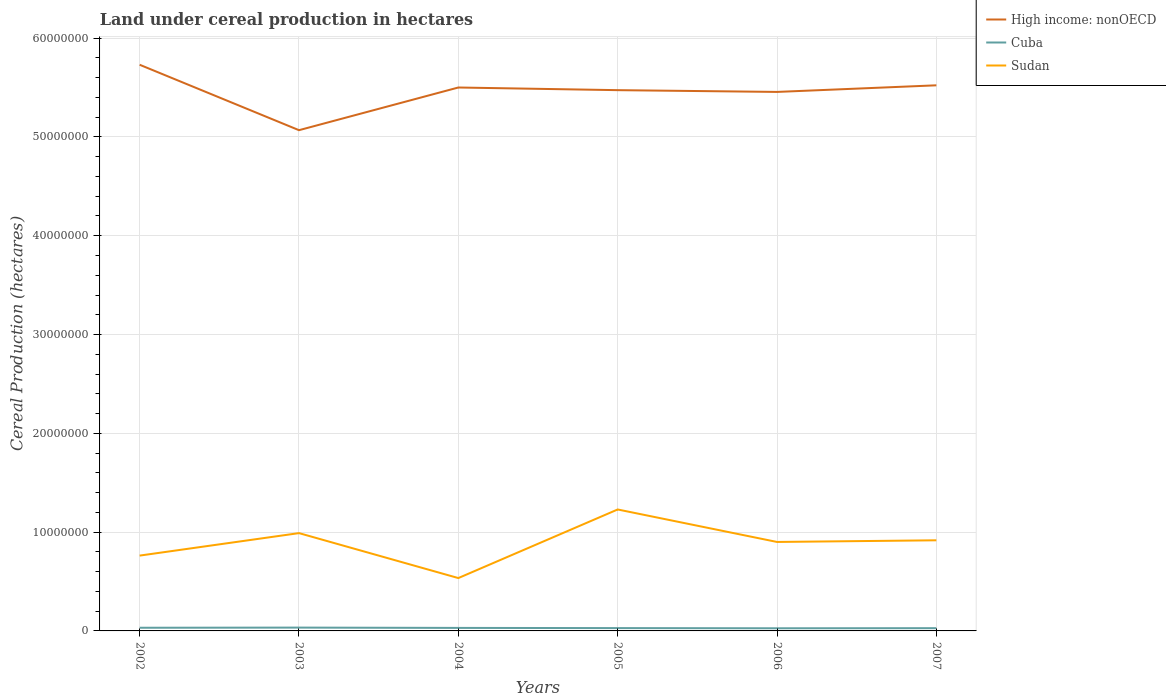Is the number of lines equal to the number of legend labels?
Make the answer very short. Yes. Across all years, what is the maximum land under cereal production in Cuba?
Ensure brevity in your answer.  2.67e+05. What is the total land under cereal production in Sudan in the graph?
Give a very brief answer. -1.38e+06. What is the difference between the highest and the second highest land under cereal production in High income: nonOECD?
Provide a short and direct response. 6.62e+06. What is the difference between the highest and the lowest land under cereal production in Cuba?
Offer a terse response. 3. Is the land under cereal production in High income: nonOECD strictly greater than the land under cereal production in Cuba over the years?
Give a very brief answer. No. How many lines are there?
Offer a very short reply. 3. What is the difference between two consecutive major ticks on the Y-axis?
Offer a terse response. 1.00e+07. What is the title of the graph?
Make the answer very short. Land under cereal production in hectares. Does "Germany" appear as one of the legend labels in the graph?
Your answer should be very brief. No. What is the label or title of the X-axis?
Offer a very short reply. Years. What is the label or title of the Y-axis?
Offer a very short reply. Cereal Production (hectares). What is the Cereal Production (hectares) of High income: nonOECD in 2002?
Your response must be concise. 5.73e+07. What is the Cereal Production (hectares) of Cuba in 2002?
Your answer should be compact. 3.21e+05. What is the Cereal Production (hectares) of Sudan in 2002?
Give a very brief answer. 7.62e+06. What is the Cereal Production (hectares) in High income: nonOECD in 2003?
Your answer should be compact. 5.07e+07. What is the Cereal Production (hectares) of Cuba in 2003?
Provide a short and direct response. 3.37e+05. What is the Cereal Production (hectares) in Sudan in 2003?
Your response must be concise. 9.90e+06. What is the Cereal Production (hectares) of High income: nonOECD in 2004?
Provide a short and direct response. 5.50e+07. What is the Cereal Production (hectares) of Cuba in 2004?
Offer a very short reply. 3.04e+05. What is the Cereal Production (hectares) in Sudan in 2004?
Give a very brief answer. 5.35e+06. What is the Cereal Production (hectares) in High income: nonOECD in 2005?
Provide a short and direct response. 5.47e+07. What is the Cereal Production (hectares) in Cuba in 2005?
Keep it short and to the point. 2.86e+05. What is the Cereal Production (hectares) in Sudan in 2005?
Provide a succinct answer. 1.23e+07. What is the Cereal Production (hectares) of High income: nonOECD in 2006?
Your response must be concise. 5.46e+07. What is the Cereal Production (hectares) of Cuba in 2006?
Provide a short and direct response. 2.67e+05. What is the Cereal Production (hectares) in Sudan in 2006?
Your response must be concise. 9.00e+06. What is the Cereal Production (hectares) of High income: nonOECD in 2007?
Offer a terse response. 5.52e+07. What is the Cereal Production (hectares) of Cuba in 2007?
Your answer should be compact. 2.78e+05. What is the Cereal Production (hectares) of Sudan in 2007?
Keep it short and to the point. 9.17e+06. Across all years, what is the maximum Cereal Production (hectares) of High income: nonOECD?
Keep it short and to the point. 5.73e+07. Across all years, what is the maximum Cereal Production (hectares) in Cuba?
Ensure brevity in your answer.  3.37e+05. Across all years, what is the maximum Cereal Production (hectares) of Sudan?
Your answer should be compact. 1.23e+07. Across all years, what is the minimum Cereal Production (hectares) of High income: nonOECD?
Provide a succinct answer. 5.07e+07. Across all years, what is the minimum Cereal Production (hectares) in Cuba?
Offer a very short reply. 2.67e+05. Across all years, what is the minimum Cereal Production (hectares) in Sudan?
Give a very brief answer. 5.35e+06. What is the total Cereal Production (hectares) of High income: nonOECD in the graph?
Make the answer very short. 3.28e+08. What is the total Cereal Production (hectares) of Cuba in the graph?
Ensure brevity in your answer.  1.79e+06. What is the total Cereal Production (hectares) of Sudan in the graph?
Provide a short and direct response. 5.33e+07. What is the difference between the Cereal Production (hectares) in High income: nonOECD in 2002 and that in 2003?
Give a very brief answer. 6.62e+06. What is the difference between the Cereal Production (hectares) of Cuba in 2002 and that in 2003?
Ensure brevity in your answer.  -1.69e+04. What is the difference between the Cereal Production (hectares) in Sudan in 2002 and that in 2003?
Ensure brevity in your answer.  -2.28e+06. What is the difference between the Cereal Production (hectares) of High income: nonOECD in 2002 and that in 2004?
Ensure brevity in your answer.  2.30e+06. What is the difference between the Cereal Production (hectares) of Cuba in 2002 and that in 2004?
Keep it short and to the point. 1.61e+04. What is the difference between the Cereal Production (hectares) in Sudan in 2002 and that in 2004?
Give a very brief answer. 2.27e+06. What is the difference between the Cereal Production (hectares) in High income: nonOECD in 2002 and that in 2005?
Make the answer very short. 2.57e+06. What is the difference between the Cereal Production (hectares) of Cuba in 2002 and that in 2005?
Offer a terse response. 3.47e+04. What is the difference between the Cereal Production (hectares) in Sudan in 2002 and that in 2005?
Offer a terse response. -4.67e+06. What is the difference between the Cereal Production (hectares) of High income: nonOECD in 2002 and that in 2006?
Make the answer very short. 2.75e+06. What is the difference between the Cereal Production (hectares) of Cuba in 2002 and that in 2006?
Your answer should be compact. 5.32e+04. What is the difference between the Cereal Production (hectares) of Sudan in 2002 and that in 2006?
Offer a very short reply. -1.38e+06. What is the difference between the Cereal Production (hectares) in High income: nonOECD in 2002 and that in 2007?
Your answer should be very brief. 2.08e+06. What is the difference between the Cereal Production (hectares) of Cuba in 2002 and that in 2007?
Make the answer very short. 4.27e+04. What is the difference between the Cereal Production (hectares) of Sudan in 2002 and that in 2007?
Give a very brief answer. -1.55e+06. What is the difference between the Cereal Production (hectares) of High income: nonOECD in 2003 and that in 2004?
Give a very brief answer. -4.32e+06. What is the difference between the Cereal Production (hectares) of Cuba in 2003 and that in 2004?
Your response must be concise. 3.30e+04. What is the difference between the Cereal Production (hectares) of Sudan in 2003 and that in 2004?
Provide a succinct answer. 4.55e+06. What is the difference between the Cereal Production (hectares) in High income: nonOECD in 2003 and that in 2005?
Provide a short and direct response. -4.05e+06. What is the difference between the Cereal Production (hectares) of Cuba in 2003 and that in 2005?
Offer a terse response. 5.16e+04. What is the difference between the Cereal Production (hectares) of Sudan in 2003 and that in 2005?
Ensure brevity in your answer.  -2.39e+06. What is the difference between the Cereal Production (hectares) in High income: nonOECD in 2003 and that in 2006?
Give a very brief answer. -3.87e+06. What is the difference between the Cereal Production (hectares) of Cuba in 2003 and that in 2006?
Provide a succinct answer. 7.00e+04. What is the difference between the Cereal Production (hectares) of Sudan in 2003 and that in 2006?
Your response must be concise. 8.95e+05. What is the difference between the Cereal Production (hectares) in High income: nonOECD in 2003 and that in 2007?
Your response must be concise. -4.54e+06. What is the difference between the Cereal Production (hectares) of Cuba in 2003 and that in 2007?
Give a very brief answer. 5.95e+04. What is the difference between the Cereal Production (hectares) of Sudan in 2003 and that in 2007?
Make the answer very short. 7.27e+05. What is the difference between the Cereal Production (hectares) of High income: nonOECD in 2004 and that in 2005?
Ensure brevity in your answer.  2.69e+05. What is the difference between the Cereal Production (hectares) in Cuba in 2004 and that in 2005?
Provide a succinct answer. 1.86e+04. What is the difference between the Cereal Production (hectares) in Sudan in 2004 and that in 2005?
Ensure brevity in your answer.  -6.94e+06. What is the difference between the Cereal Production (hectares) in High income: nonOECD in 2004 and that in 2006?
Your response must be concise. 4.48e+05. What is the difference between the Cereal Production (hectares) in Cuba in 2004 and that in 2006?
Give a very brief answer. 3.70e+04. What is the difference between the Cereal Production (hectares) of Sudan in 2004 and that in 2006?
Give a very brief answer. -3.65e+06. What is the difference between the Cereal Production (hectares) of High income: nonOECD in 2004 and that in 2007?
Your answer should be compact. -2.21e+05. What is the difference between the Cereal Production (hectares) of Cuba in 2004 and that in 2007?
Your response must be concise. 2.65e+04. What is the difference between the Cereal Production (hectares) of Sudan in 2004 and that in 2007?
Provide a short and direct response. -3.82e+06. What is the difference between the Cereal Production (hectares) in High income: nonOECD in 2005 and that in 2006?
Your answer should be compact. 1.79e+05. What is the difference between the Cereal Production (hectares) of Cuba in 2005 and that in 2006?
Provide a short and direct response. 1.84e+04. What is the difference between the Cereal Production (hectares) of Sudan in 2005 and that in 2006?
Your response must be concise. 3.29e+06. What is the difference between the Cereal Production (hectares) in High income: nonOECD in 2005 and that in 2007?
Keep it short and to the point. -4.91e+05. What is the difference between the Cereal Production (hectares) of Cuba in 2005 and that in 2007?
Your answer should be compact. 7947. What is the difference between the Cereal Production (hectares) of Sudan in 2005 and that in 2007?
Make the answer very short. 3.12e+06. What is the difference between the Cereal Production (hectares) in High income: nonOECD in 2006 and that in 2007?
Your answer should be compact. -6.69e+05. What is the difference between the Cereal Production (hectares) in Cuba in 2006 and that in 2007?
Your answer should be compact. -1.05e+04. What is the difference between the Cereal Production (hectares) in Sudan in 2006 and that in 2007?
Your response must be concise. -1.68e+05. What is the difference between the Cereal Production (hectares) of High income: nonOECD in 2002 and the Cereal Production (hectares) of Cuba in 2003?
Your answer should be compact. 5.70e+07. What is the difference between the Cereal Production (hectares) of High income: nonOECD in 2002 and the Cereal Production (hectares) of Sudan in 2003?
Your answer should be very brief. 4.74e+07. What is the difference between the Cereal Production (hectares) of Cuba in 2002 and the Cereal Production (hectares) of Sudan in 2003?
Make the answer very short. -9.58e+06. What is the difference between the Cereal Production (hectares) in High income: nonOECD in 2002 and the Cereal Production (hectares) in Cuba in 2004?
Your response must be concise. 5.70e+07. What is the difference between the Cereal Production (hectares) of High income: nonOECD in 2002 and the Cereal Production (hectares) of Sudan in 2004?
Offer a very short reply. 5.20e+07. What is the difference between the Cereal Production (hectares) of Cuba in 2002 and the Cereal Production (hectares) of Sudan in 2004?
Make the answer very short. -5.03e+06. What is the difference between the Cereal Production (hectares) in High income: nonOECD in 2002 and the Cereal Production (hectares) in Cuba in 2005?
Your answer should be compact. 5.70e+07. What is the difference between the Cereal Production (hectares) in High income: nonOECD in 2002 and the Cereal Production (hectares) in Sudan in 2005?
Offer a very short reply. 4.50e+07. What is the difference between the Cereal Production (hectares) in Cuba in 2002 and the Cereal Production (hectares) in Sudan in 2005?
Your answer should be compact. -1.20e+07. What is the difference between the Cereal Production (hectares) in High income: nonOECD in 2002 and the Cereal Production (hectares) in Cuba in 2006?
Offer a very short reply. 5.70e+07. What is the difference between the Cereal Production (hectares) in High income: nonOECD in 2002 and the Cereal Production (hectares) in Sudan in 2006?
Keep it short and to the point. 4.83e+07. What is the difference between the Cereal Production (hectares) in Cuba in 2002 and the Cereal Production (hectares) in Sudan in 2006?
Make the answer very short. -8.68e+06. What is the difference between the Cereal Production (hectares) in High income: nonOECD in 2002 and the Cereal Production (hectares) in Cuba in 2007?
Provide a short and direct response. 5.70e+07. What is the difference between the Cereal Production (hectares) in High income: nonOECD in 2002 and the Cereal Production (hectares) in Sudan in 2007?
Keep it short and to the point. 4.81e+07. What is the difference between the Cereal Production (hectares) in Cuba in 2002 and the Cereal Production (hectares) in Sudan in 2007?
Provide a succinct answer. -8.85e+06. What is the difference between the Cereal Production (hectares) of High income: nonOECD in 2003 and the Cereal Production (hectares) of Cuba in 2004?
Offer a terse response. 5.04e+07. What is the difference between the Cereal Production (hectares) in High income: nonOECD in 2003 and the Cereal Production (hectares) in Sudan in 2004?
Keep it short and to the point. 4.53e+07. What is the difference between the Cereal Production (hectares) in Cuba in 2003 and the Cereal Production (hectares) in Sudan in 2004?
Offer a terse response. -5.01e+06. What is the difference between the Cereal Production (hectares) in High income: nonOECD in 2003 and the Cereal Production (hectares) in Cuba in 2005?
Provide a succinct answer. 5.04e+07. What is the difference between the Cereal Production (hectares) in High income: nonOECD in 2003 and the Cereal Production (hectares) in Sudan in 2005?
Ensure brevity in your answer.  3.84e+07. What is the difference between the Cereal Production (hectares) of Cuba in 2003 and the Cereal Production (hectares) of Sudan in 2005?
Your response must be concise. -1.20e+07. What is the difference between the Cereal Production (hectares) of High income: nonOECD in 2003 and the Cereal Production (hectares) of Cuba in 2006?
Give a very brief answer. 5.04e+07. What is the difference between the Cereal Production (hectares) in High income: nonOECD in 2003 and the Cereal Production (hectares) in Sudan in 2006?
Provide a succinct answer. 4.17e+07. What is the difference between the Cereal Production (hectares) of Cuba in 2003 and the Cereal Production (hectares) of Sudan in 2006?
Your answer should be compact. -8.67e+06. What is the difference between the Cereal Production (hectares) in High income: nonOECD in 2003 and the Cereal Production (hectares) in Cuba in 2007?
Provide a succinct answer. 5.04e+07. What is the difference between the Cereal Production (hectares) in High income: nonOECD in 2003 and the Cereal Production (hectares) in Sudan in 2007?
Offer a very short reply. 4.15e+07. What is the difference between the Cereal Production (hectares) of Cuba in 2003 and the Cereal Production (hectares) of Sudan in 2007?
Your answer should be very brief. -8.84e+06. What is the difference between the Cereal Production (hectares) in High income: nonOECD in 2004 and the Cereal Production (hectares) in Cuba in 2005?
Make the answer very short. 5.47e+07. What is the difference between the Cereal Production (hectares) in High income: nonOECD in 2004 and the Cereal Production (hectares) in Sudan in 2005?
Keep it short and to the point. 4.27e+07. What is the difference between the Cereal Production (hectares) in Cuba in 2004 and the Cereal Production (hectares) in Sudan in 2005?
Offer a very short reply. -1.20e+07. What is the difference between the Cereal Production (hectares) in High income: nonOECD in 2004 and the Cereal Production (hectares) in Cuba in 2006?
Ensure brevity in your answer.  5.47e+07. What is the difference between the Cereal Production (hectares) in High income: nonOECD in 2004 and the Cereal Production (hectares) in Sudan in 2006?
Give a very brief answer. 4.60e+07. What is the difference between the Cereal Production (hectares) in Cuba in 2004 and the Cereal Production (hectares) in Sudan in 2006?
Give a very brief answer. -8.70e+06. What is the difference between the Cereal Production (hectares) of High income: nonOECD in 2004 and the Cereal Production (hectares) of Cuba in 2007?
Give a very brief answer. 5.47e+07. What is the difference between the Cereal Production (hectares) in High income: nonOECD in 2004 and the Cereal Production (hectares) in Sudan in 2007?
Ensure brevity in your answer.  4.58e+07. What is the difference between the Cereal Production (hectares) in Cuba in 2004 and the Cereal Production (hectares) in Sudan in 2007?
Ensure brevity in your answer.  -8.87e+06. What is the difference between the Cereal Production (hectares) of High income: nonOECD in 2005 and the Cereal Production (hectares) of Cuba in 2006?
Provide a short and direct response. 5.45e+07. What is the difference between the Cereal Production (hectares) of High income: nonOECD in 2005 and the Cereal Production (hectares) of Sudan in 2006?
Your answer should be very brief. 4.57e+07. What is the difference between the Cereal Production (hectares) of Cuba in 2005 and the Cereal Production (hectares) of Sudan in 2006?
Offer a terse response. -8.72e+06. What is the difference between the Cereal Production (hectares) in High income: nonOECD in 2005 and the Cereal Production (hectares) in Cuba in 2007?
Your answer should be compact. 5.45e+07. What is the difference between the Cereal Production (hectares) in High income: nonOECD in 2005 and the Cereal Production (hectares) in Sudan in 2007?
Your answer should be very brief. 4.56e+07. What is the difference between the Cereal Production (hectares) of Cuba in 2005 and the Cereal Production (hectares) of Sudan in 2007?
Ensure brevity in your answer.  -8.89e+06. What is the difference between the Cereal Production (hectares) of High income: nonOECD in 2006 and the Cereal Production (hectares) of Cuba in 2007?
Offer a terse response. 5.43e+07. What is the difference between the Cereal Production (hectares) of High income: nonOECD in 2006 and the Cereal Production (hectares) of Sudan in 2007?
Make the answer very short. 4.54e+07. What is the difference between the Cereal Production (hectares) of Cuba in 2006 and the Cereal Production (hectares) of Sudan in 2007?
Your answer should be compact. -8.91e+06. What is the average Cereal Production (hectares) in High income: nonOECD per year?
Ensure brevity in your answer.  5.46e+07. What is the average Cereal Production (hectares) of Cuba per year?
Provide a succinct answer. 2.99e+05. What is the average Cereal Production (hectares) of Sudan per year?
Make the answer very short. 8.89e+06. In the year 2002, what is the difference between the Cereal Production (hectares) in High income: nonOECD and Cereal Production (hectares) in Cuba?
Offer a terse response. 5.70e+07. In the year 2002, what is the difference between the Cereal Production (hectares) in High income: nonOECD and Cereal Production (hectares) in Sudan?
Your response must be concise. 4.97e+07. In the year 2002, what is the difference between the Cereal Production (hectares) in Cuba and Cereal Production (hectares) in Sudan?
Keep it short and to the point. -7.30e+06. In the year 2003, what is the difference between the Cereal Production (hectares) of High income: nonOECD and Cereal Production (hectares) of Cuba?
Your response must be concise. 5.03e+07. In the year 2003, what is the difference between the Cereal Production (hectares) in High income: nonOECD and Cereal Production (hectares) in Sudan?
Offer a very short reply. 4.08e+07. In the year 2003, what is the difference between the Cereal Production (hectares) of Cuba and Cereal Production (hectares) of Sudan?
Provide a short and direct response. -9.56e+06. In the year 2004, what is the difference between the Cereal Production (hectares) in High income: nonOECD and Cereal Production (hectares) in Cuba?
Make the answer very short. 5.47e+07. In the year 2004, what is the difference between the Cereal Production (hectares) of High income: nonOECD and Cereal Production (hectares) of Sudan?
Your answer should be very brief. 4.97e+07. In the year 2004, what is the difference between the Cereal Production (hectares) in Cuba and Cereal Production (hectares) in Sudan?
Provide a short and direct response. -5.05e+06. In the year 2005, what is the difference between the Cereal Production (hectares) of High income: nonOECD and Cereal Production (hectares) of Cuba?
Your answer should be compact. 5.44e+07. In the year 2005, what is the difference between the Cereal Production (hectares) in High income: nonOECD and Cereal Production (hectares) in Sudan?
Keep it short and to the point. 4.24e+07. In the year 2005, what is the difference between the Cereal Production (hectares) in Cuba and Cereal Production (hectares) in Sudan?
Make the answer very short. -1.20e+07. In the year 2006, what is the difference between the Cereal Production (hectares) in High income: nonOECD and Cereal Production (hectares) in Cuba?
Your answer should be very brief. 5.43e+07. In the year 2006, what is the difference between the Cereal Production (hectares) of High income: nonOECD and Cereal Production (hectares) of Sudan?
Provide a short and direct response. 4.56e+07. In the year 2006, what is the difference between the Cereal Production (hectares) in Cuba and Cereal Production (hectares) in Sudan?
Offer a terse response. -8.74e+06. In the year 2007, what is the difference between the Cereal Production (hectares) in High income: nonOECD and Cereal Production (hectares) in Cuba?
Your answer should be very brief. 5.49e+07. In the year 2007, what is the difference between the Cereal Production (hectares) in High income: nonOECD and Cereal Production (hectares) in Sudan?
Offer a terse response. 4.61e+07. In the year 2007, what is the difference between the Cereal Production (hectares) of Cuba and Cereal Production (hectares) of Sudan?
Keep it short and to the point. -8.89e+06. What is the ratio of the Cereal Production (hectares) of High income: nonOECD in 2002 to that in 2003?
Your answer should be compact. 1.13. What is the ratio of the Cereal Production (hectares) in Cuba in 2002 to that in 2003?
Offer a very short reply. 0.95. What is the ratio of the Cereal Production (hectares) in Sudan in 2002 to that in 2003?
Keep it short and to the point. 0.77. What is the ratio of the Cereal Production (hectares) in High income: nonOECD in 2002 to that in 2004?
Your response must be concise. 1.04. What is the ratio of the Cereal Production (hectares) in Cuba in 2002 to that in 2004?
Keep it short and to the point. 1.05. What is the ratio of the Cereal Production (hectares) in Sudan in 2002 to that in 2004?
Offer a very short reply. 1.43. What is the ratio of the Cereal Production (hectares) in High income: nonOECD in 2002 to that in 2005?
Offer a terse response. 1.05. What is the ratio of the Cereal Production (hectares) of Cuba in 2002 to that in 2005?
Give a very brief answer. 1.12. What is the ratio of the Cereal Production (hectares) in Sudan in 2002 to that in 2005?
Provide a short and direct response. 0.62. What is the ratio of the Cereal Production (hectares) of High income: nonOECD in 2002 to that in 2006?
Make the answer very short. 1.05. What is the ratio of the Cereal Production (hectares) in Cuba in 2002 to that in 2006?
Provide a short and direct response. 1.2. What is the ratio of the Cereal Production (hectares) of Sudan in 2002 to that in 2006?
Your answer should be compact. 0.85. What is the ratio of the Cereal Production (hectares) of High income: nonOECD in 2002 to that in 2007?
Give a very brief answer. 1.04. What is the ratio of the Cereal Production (hectares) in Cuba in 2002 to that in 2007?
Make the answer very short. 1.15. What is the ratio of the Cereal Production (hectares) of Sudan in 2002 to that in 2007?
Offer a very short reply. 0.83. What is the ratio of the Cereal Production (hectares) in High income: nonOECD in 2003 to that in 2004?
Give a very brief answer. 0.92. What is the ratio of the Cereal Production (hectares) in Cuba in 2003 to that in 2004?
Provide a succinct answer. 1.11. What is the ratio of the Cereal Production (hectares) in Sudan in 2003 to that in 2004?
Your response must be concise. 1.85. What is the ratio of the Cereal Production (hectares) of High income: nonOECD in 2003 to that in 2005?
Make the answer very short. 0.93. What is the ratio of the Cereal Production (hectares) of Cuba in 2003 to that in 2005?
Provide a succinct answer. 1.18. What is the ratio of the Cereal Production (hectares) of Sudan in 2003 to that in 2005?
Provide a short and direct response. 0.81. What is the ratio of the Cereal Production (hectares) of High income: nonOECD in 2003 to that in 2006?
Make the answer very short. 0.93. What is the ratio of the Cereal Production (hectares) in Cuba in 2003 to that in 2006?
Offer a very short reply. 1.26. What is the ratio of the Cereal Production (hectares) in Sudan in 2003 to that in 2006?
Your answer should be compact. 1.1. What is the ratio of the Cereal Production (hectares) of High income: nonOECD in 2003 to that in 2007?
Offer a very short reply. 0.92. What is the ratio of the Cereal Production (hectares) of Cuba in 2003 to that in 2007?
Make the answer very short. 1.21. What is the ratio of the Cereal Production (hectares) of Sudan in 2003 to that in 2007?
Your answer should be very brief. 1.08. What is the ratio of the Cereal Production (hectares) in Cuba in 2004 to that in 2005?
Your answer should be compact. 1.06. What is the ratio of the Cereal Production (hectares) in Sudan in 2004 to that in 2005?
Give a very brief answer. 0.44. What is the ratio of the Cereal Production (hectares) in High income: nonOECD in 2004 to that in 2006?
Your answer should be compact. 1.01. What is the ratio of the Cereal Production (hectares) in Cuba in 2004 to that in 2006?
Your answer should be compact. 1.14. What is the ratio of the Cereal Production (hectares) in Sudan in 2004 to that in 2006?
Offer a terse response. 0.59. What is the ratio of the Cereal Production (hectares) of Cuba in 2004 to that in 2007?
Your response must be concise. 1.1. What is the ratio of the Cereal Production (hectares) of Sudan in 2004 to that in 2007?
Your answer should be compact. 0.58. What is the ratio of the Cereal Production (hectares) of High income: nonOECD in 2005 to that in 2006?
Offer a very short reply. 1. What is the ratio of the Cereal Production (hectares) of Cuba in 2005 to that in 2006?
Make the answer very short. 1.07. What is the ratio of the Cereal Production (hectares) of Sudan in 2005 to that in 2006?
Ensure brevity in your answer.  1.37. What is the ratio of the Cereal Production (hectares) in Cuba in 2005 to that in 2007?
Make the answer very short. 1.03. What is the ratio of the Cereal Production (hectares) of Sudan in 2005 to that in 2007?
Provide a succinct answer. 1.34. What is the ratio of the Cereal Production (hectares) of High income: nonOECD in 2006 to that in 2007?
Keep it short and to the point. 0.99. What is the ratio of the Cereal Production (hectares) in Cuba in 2006 to that in 2007?
Keep it short and to the point. 0.96. What is the ratio of the Cereal Production (hectares) in Sudan in 2006 to that in 2007?
Your answer should be compact. 0.98. What is the difference between the highest and the second highest Cereal Production (hectares) in High income: nonOECD?
Give a very brief answer. 2.08e+06. What is the difference between the highest and the second highest Cereal Production (hectares) of Cuba?
Provide a succinct answer. 1.69e+04. What is the difference between the highest and the second highest Cereal Production (hectares) in Sudan?
Give a very brief answer. 2.39e+06. What is the difference between the highest and the lowest Cereal Production (hectares) of High income: nonOECD?
Offer a terse response. 6.62e+06. What is the difference between the highest and the lowest Cereal Production (hectares) of Cuba?
Offer a very short reply. 7.00e+04. What is the difference between the highest and the lowest Cereal Production (hectares) in Sudan?
Your answer should be compact. 6.94e+06. 